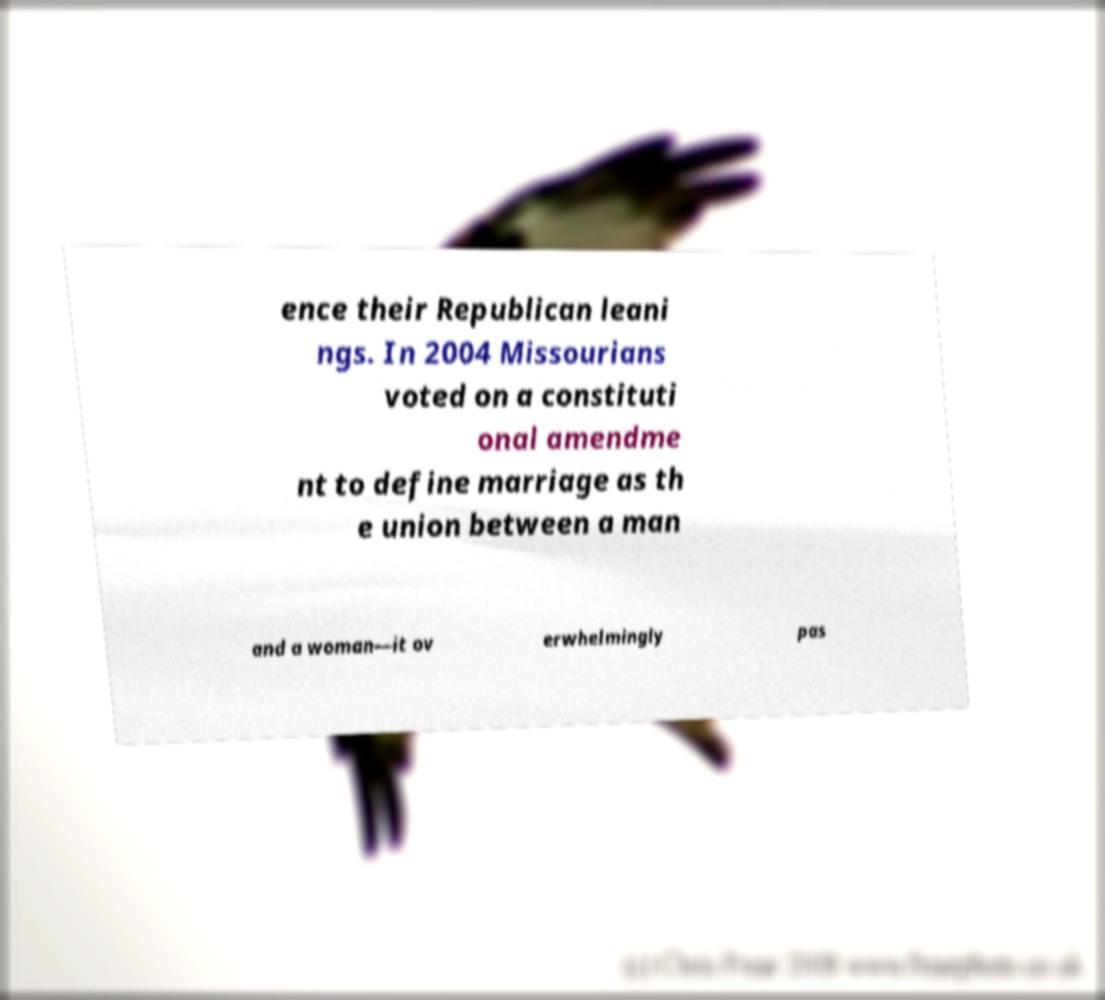Can you accurately transcribe the text from the provided image for me? ence their Republican leani ngs. In 2004 Missourians voted on a constituti onal amendme nt to define marriage as th e union between a man and a woman—it ov erwhelmingly pas 